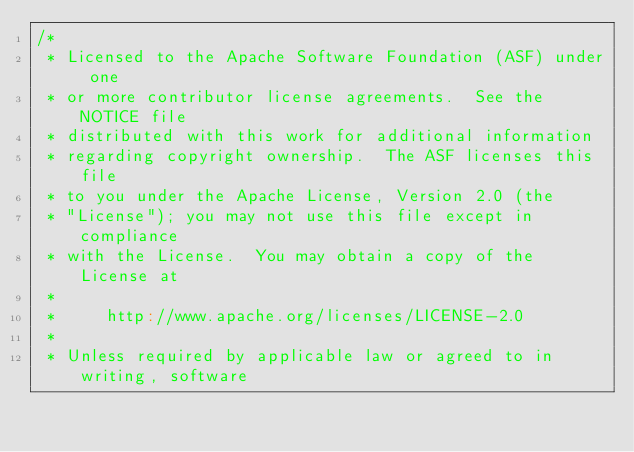Convert code to text. <code><loc_0><loc_0><loc_500><loc_500><_Scala_>/*
 * Licensed to the Apache Software Foundation (ASF) under one
 * or more contributor license agreements.  See the NOTICE file
 * distributed with this work for additional information
 * regarding copyright ownership.  The ASF licenses this file
 * to you under the Apache License, Version 2.0 (the
 * "License"); you may not use this file except in compliance
 * with the License.  You may obtain a copy of the License at
 *
 *     http://www.apache.org/licenses/LICENSE-2.0
 *
 * Unless required by applicable law or agreed to in writing, software</code> 